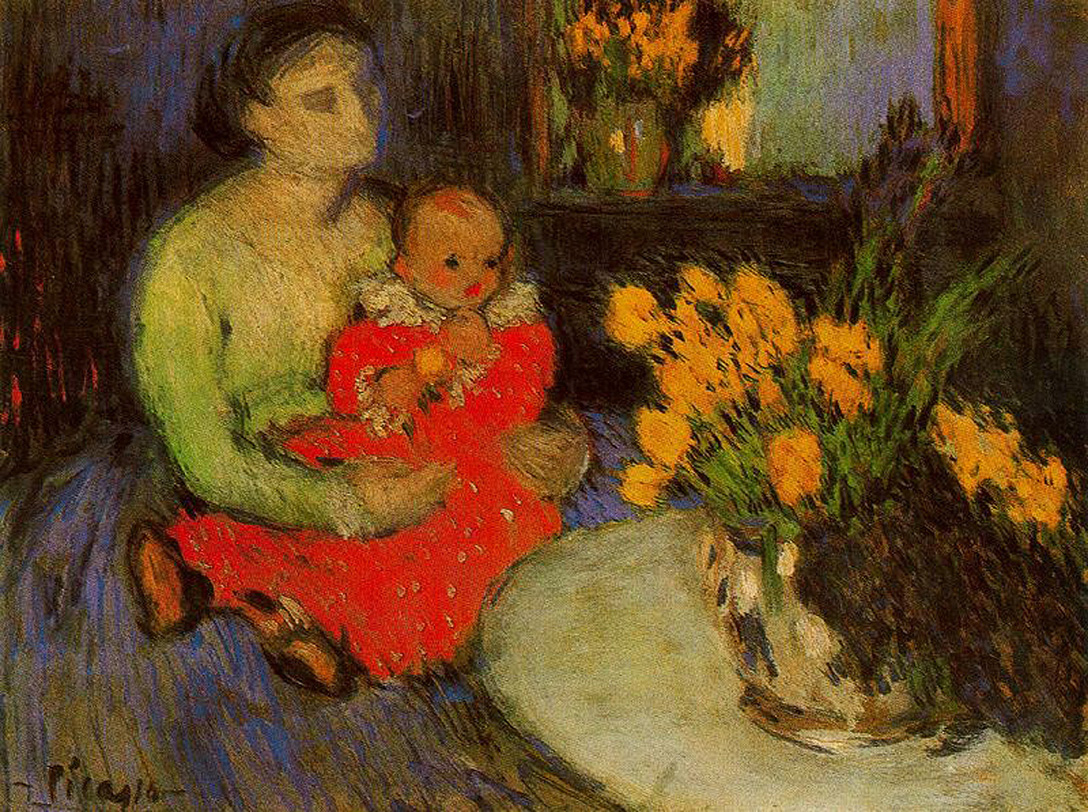If the scene were to come to life, what sounds do you think would accompany it? Should the scene come to life, one might hear the soft humming of the mother as she soothes her child. Gentle whispers of a lullaby fill the air, mingling with the distant chirping of birds outside the window. The rustle of the leaves from the trees outside accompanies the occasional soft laugh of the child. Perhaps you’d also hear the faint, rhythmic ticking of a clock, marking the slow passage of time in this serene moment. The quiet rustle of fabric as the mother shifts to hold her child more comfortably and the very soft breeze weaving in with the scent of the flowers add to the peaceful ambiance. Imagine this painting in an alternate fantasy universe. What magical elements could be present? In an alternate fantasy universe, this painting could be rich with enchantment. The flowers in the vase might occasionally bloom into vibrant, shimmering lights that float and dance around the room, casting colorful glows on the walls. The mother and child could be magical beings; perhaps the child holds a small, glittering orb that changes colors and brings warmth to the room. The dimly lit background could house tiny, luminescent fairies flitting about, whispering secrets and songs. The mother’s dress might be woven from threads of moonlight, shimmering gently with every movement, and each brushstroke could seem to come alive, subtly shifting and changing, adding a dynamic, almost living quality to the painting. 